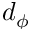Convert formula to latex. <formula><loc_0><loc_0><loc_500><loc_500>d _ { \phi }</formula> 